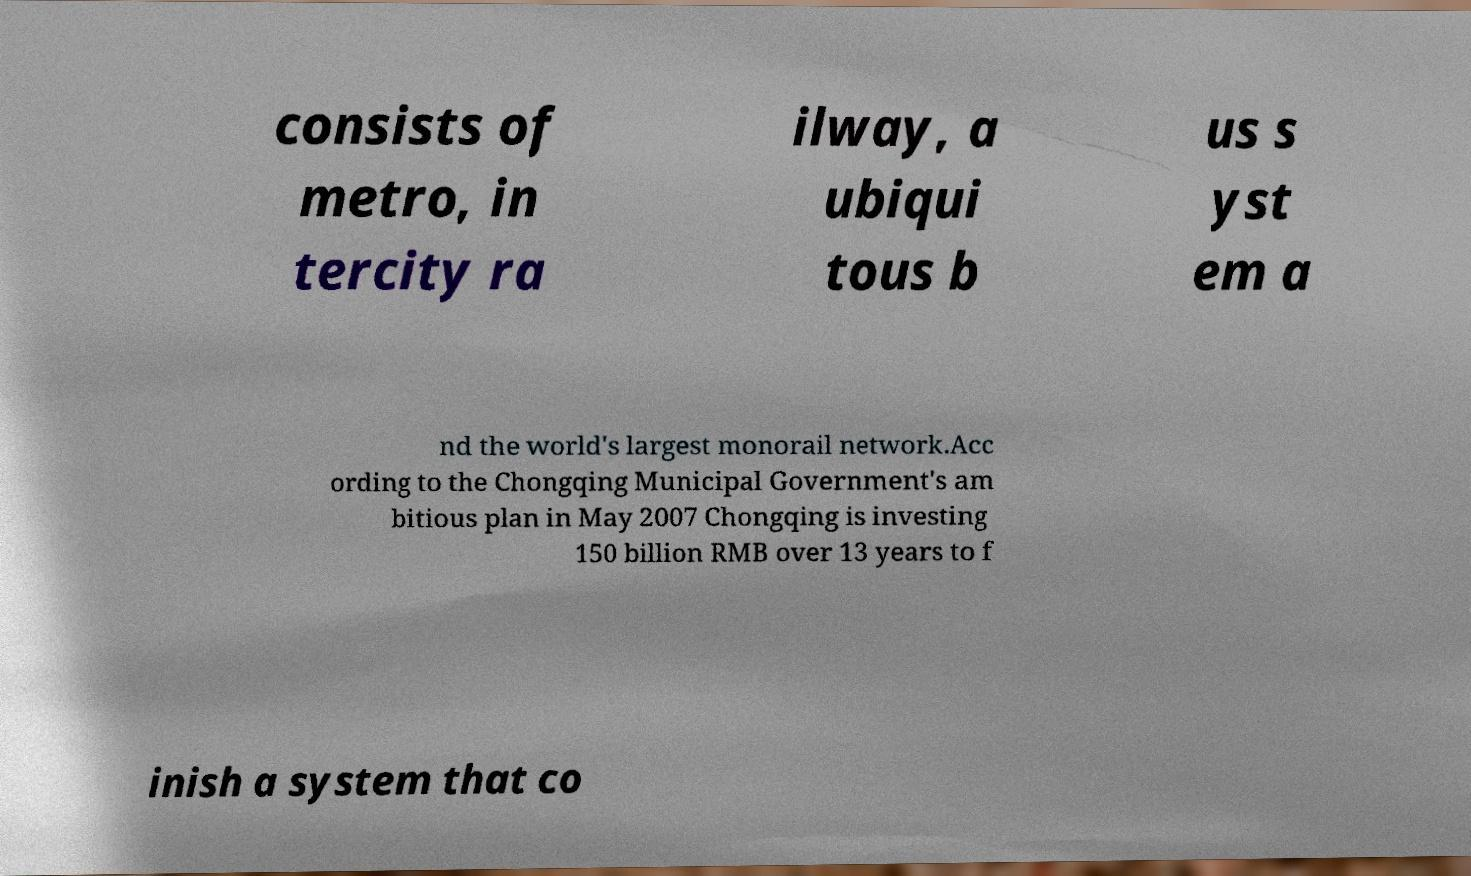Could you assist in decoding the text presented in this image and type it out clearly? consists of metro, in tercity ra ilway, a ubiqui tous b us s yst em a nd the world's largest monorail network.Acc ording to the Chongqing Municipal Government's am bitious plan in May 2007 Chongqing is investing 150 billion RMB over 13 years to f inish a system that co 